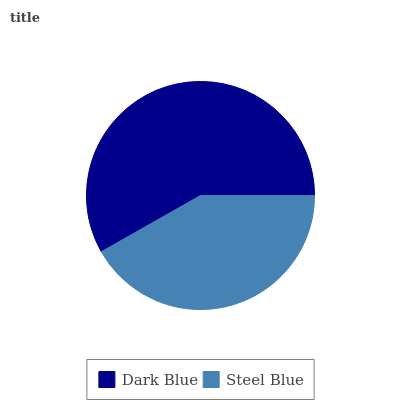Is Steel Blue the minimum?
Answer yes or no. Yes. Is Dark Blue the maximum?
Answer yes or no. Yes. Is Steel Blue the maximum?
Answer yes or no. No. Is Dark Blue greater than Steel Blue?
Answer yes or no. Yes. Is Steel Blue less than Dark Blue?
Answer yes or no. Yes. Is Steel Blue greater than Dark Blue?
Answer yes or no. No. Is Dark Blue less than Steel Blue?
Answer yes or no. No. Is Dark Blue the high median?
Answer yes or no. Yes. Is Steel Blue the low median?
Answer yes or no. Yes. Is Steel Blue the high median?
Answer yes or no. No. Is Dark Blue the low median?
Answer yes or no. No. 